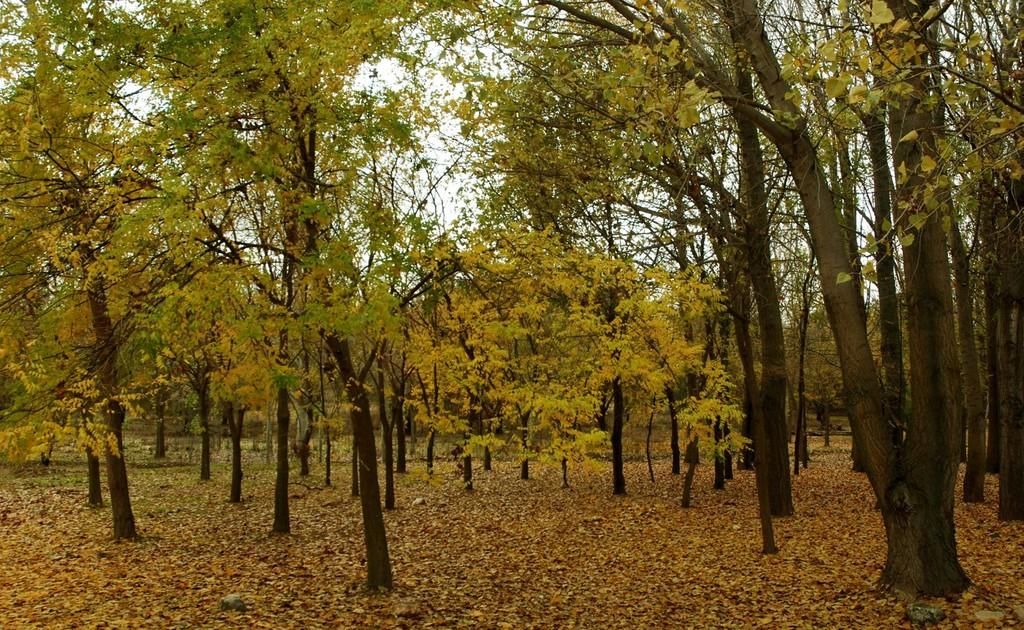What type of vegetation can be seen in the image? There are trees in the image. What is present on the surface in the image? Dry leaves are present on the surface in the image. What type of amusement can be seen in the image? There is no amusement present in the image; it only features trees and dry leaves. What type of jeans are visible in the image? There are no jeans present in the image. 